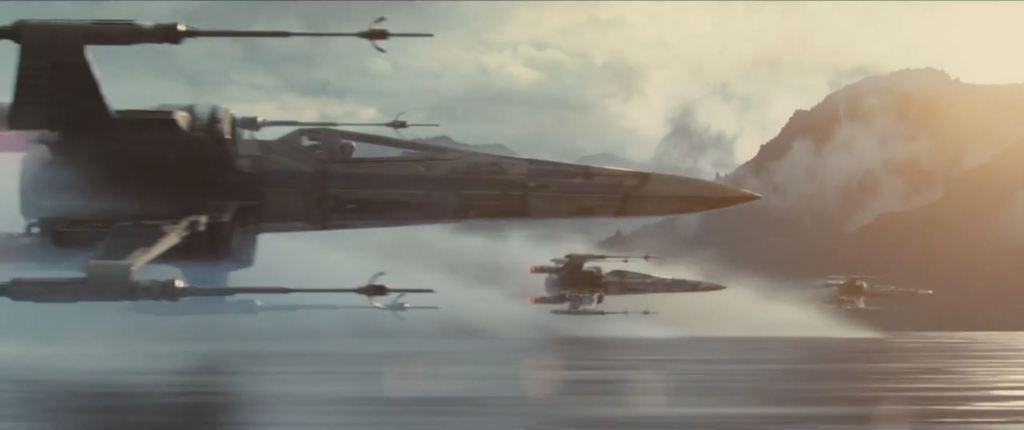What is happening in the image? There are planes flying in the image. What natural feature can be seen in the image? There is a mountain visible in the image. What type of breakfast is being served on the canvas in the image? There is no canvas or breakfast present in the image; it features planes flying and a mountain. 